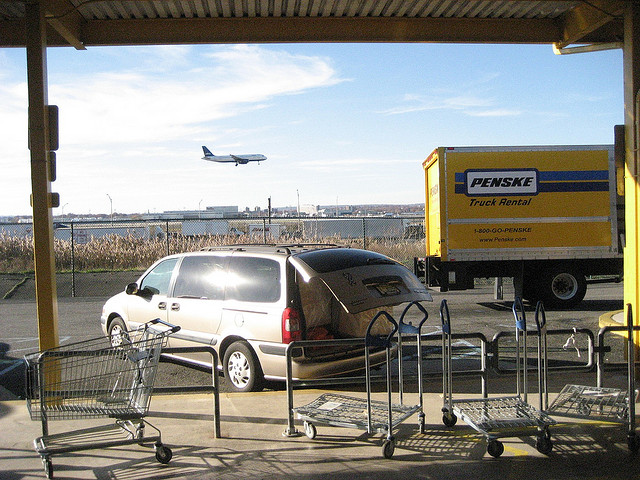Please identify all text content in this image. PENSKE RentaL Truck 